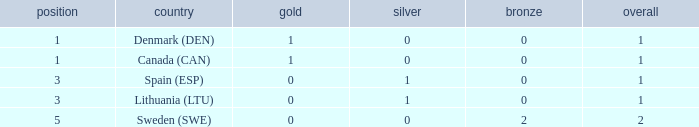What is the rank when there is 0 gold, the total is more than 1, and silver is more than 0? None. 